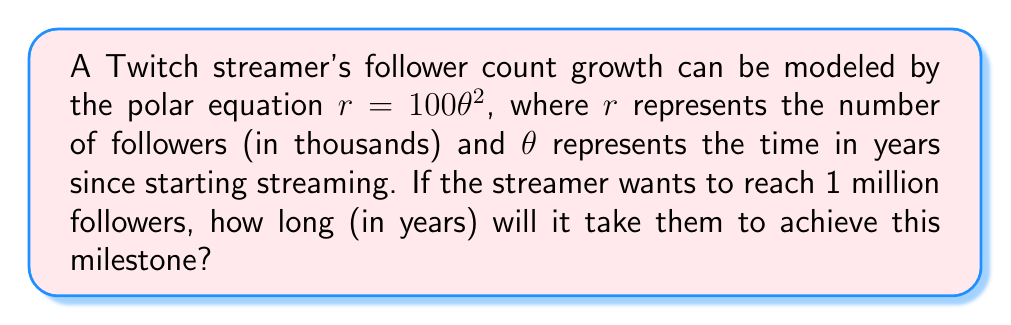Could you help me with this problem? To solve this problem, we need to follow these steps:

1) First, we need to convert 1 million followers to the units used in the equation. Since $r$ is in thousands of followers:

   1 million = 1000 thousand

2) Now, we can set up our equation:

   $r = 100\theta^2$
   $1000 = 100\theta^2$

3) Solve for $\theta$:

   $\frac{1000}{100} = \theta^2$
   $10 = \theta^2$

4) Take the square root of both sides:

   $\sqrt{10} = \theta$

5) Simplify:

   $\theta \approx 3.16$

The value of $\theta$ represents the number of years it will take to reach 1 million followers.

This growth model using a polar equation demonstrates how a streamer's follower count can accelerate over time, which is often seen in successful Twitch careers. The quadratic nature of the equation ($\theta^2$) reflects the potential for exponential growth as a streamer gains popularity and exposure on the platform.
Answer: It will take approximately 3.16 years for the Twitch streamer to reach 1 million followers. 